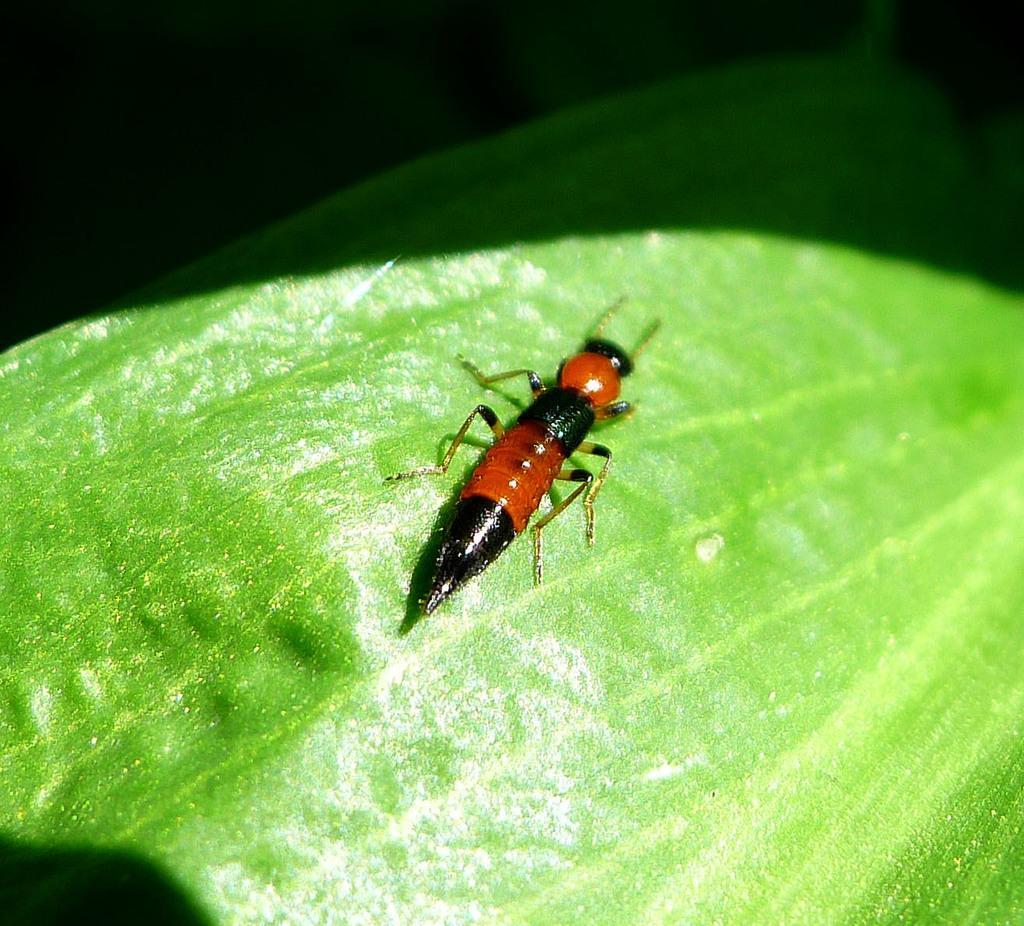How would you summarize this image in a sentence or two? In this picture I can see an insect which is of black and red color and it is on a leaf. 